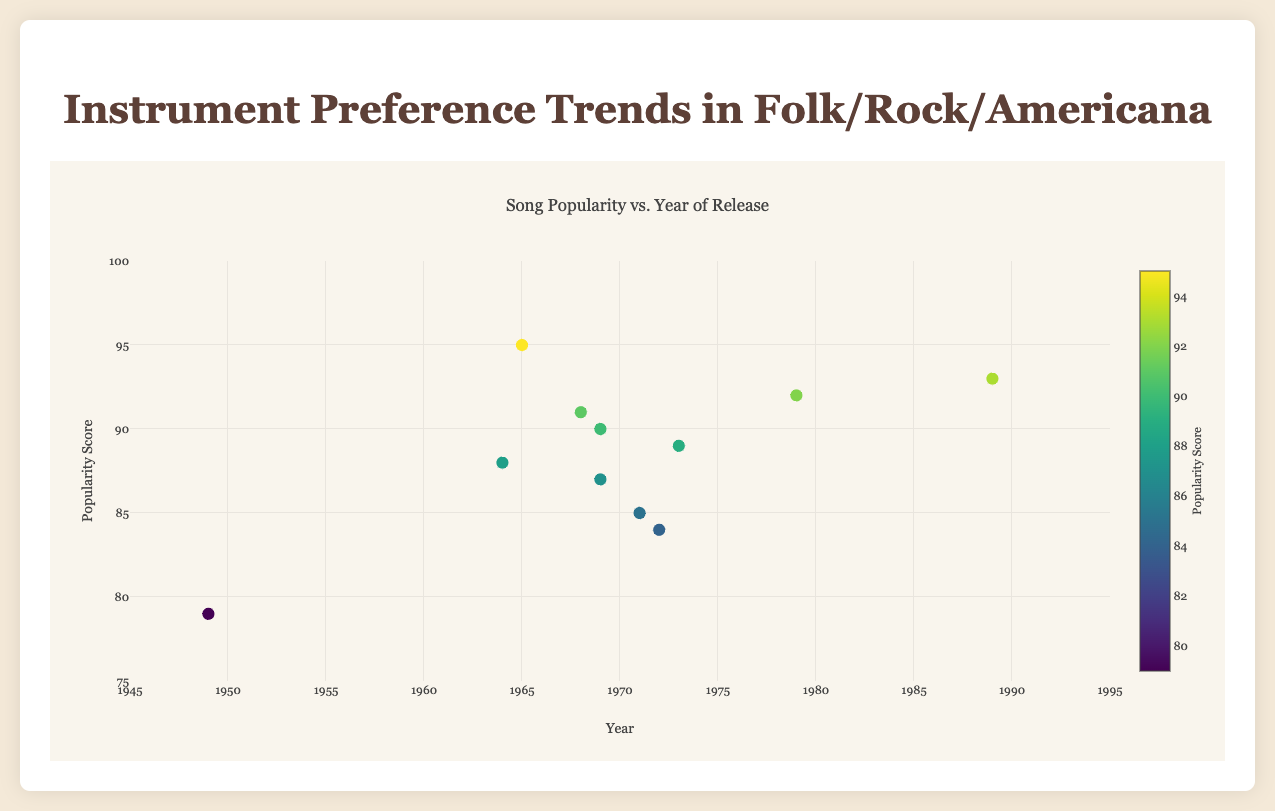What's the title of the figure? The title of the figure is printed at the top of the plot, clearly indicating its content.
Answer: Instrument Preference Trends in Folk/Rock/Americana Which song has the highest popularity score? The highest data point on the y-axis corresponds to "Like a Rolling Stone" by Bob Dylan, with a score of 95.
Answer: Like a Rolling Stone How many songs have a popularity score greater than 90? By looking for data points above the 90 mark on the y-axis, we find "The Devil Went Down to Georgia," "The Weight," "Fortunate Son," "Rockin' in the Free World," and "Like a Rolling Stone."
Answer: 5 What is the popularity score of "Piano Man"? Locate "Piano Man" by Billy Joel on the plot to see its popularity score, which matches the label.
Answer: 89 How does "Foggy Mountain Breakdown" compare to "The Devil Went Down to Georgia" in terms of popularity score? Identify both songs on the plot and compare their y-axis values. "Foggy Mountain Breakdown" has a score of 79, while "The Devil Went Down to Georgia" has 92.
Answer: The Devil Went Down to Georgia is more popular Which instrument is associated with the song having the lowest popularity score? Find the data point with the lowest y-axis value, which corresponds to the song "Foggy Mountain Breakdown" using the banjo.
Answer: Banjo What is the average popularity score of all the songs listed? Sum up all popularity scores (87 + 79 + 85 + 92 + 88 + 84 + 91 + 90 + 93 + 89 + 95 = 973) and divide by the number of songs (11). 973 / 11 = 88.45
Answer: 88.45 Do songs from the 1960s generally have higher or lower popularity scores compared to songs from the 1970s? Compare the concentration of points from each decade on the plot. Songs from the 1960s include scores of 87, 88, 91, and 95. Songs from the 1970s have: 85, 84, 89, and 92. Average these for comparison: (87 + 88 + 91 + 95)/4 = 90.25 for the 1960s and (85 + 84 + 89 + 92)/4 = 87.5 for the 1970s.
Answer: 1960s Is there a clear trend over time in the popularity scores? Observe the scatter plot to see if there's an upward or downward slope in the data points across the years. The plot appears to show no clear trend over the years.
Answer: No clear trend 